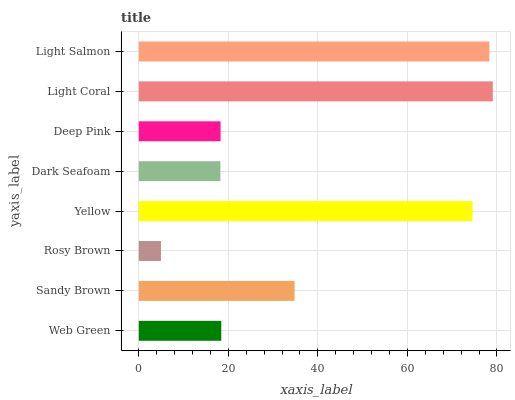Is Rosy Brown the minimum?
Answer yes or no. Yes. Is Light Coral the maximum?
Answer yes or no. Yes. Is Sandy Brown the minimum?
Answer yes or no. No. Is Sandy Brown the maximum?
Answer yes or no. No. Is Sandy Brown greater than Web Green?
Answer yes or no. Yes. Is Web Green less than Sandy Brown?
Answer yes or no. Yes. Is Web Green greater than Sandy Brown?
Answer yes or no. No. Is Sandy Brown less than Web Green?
Answer yes or no. No. Is Sandy Brown the high median?
Answer yes or no. Yes. Is Web Green the low median?
Answer yes or no. Yes. Is Deep Pink the high median?
Answer yes or no. No. Is Sandy Brown the low median?
Answer yes or no. No. 